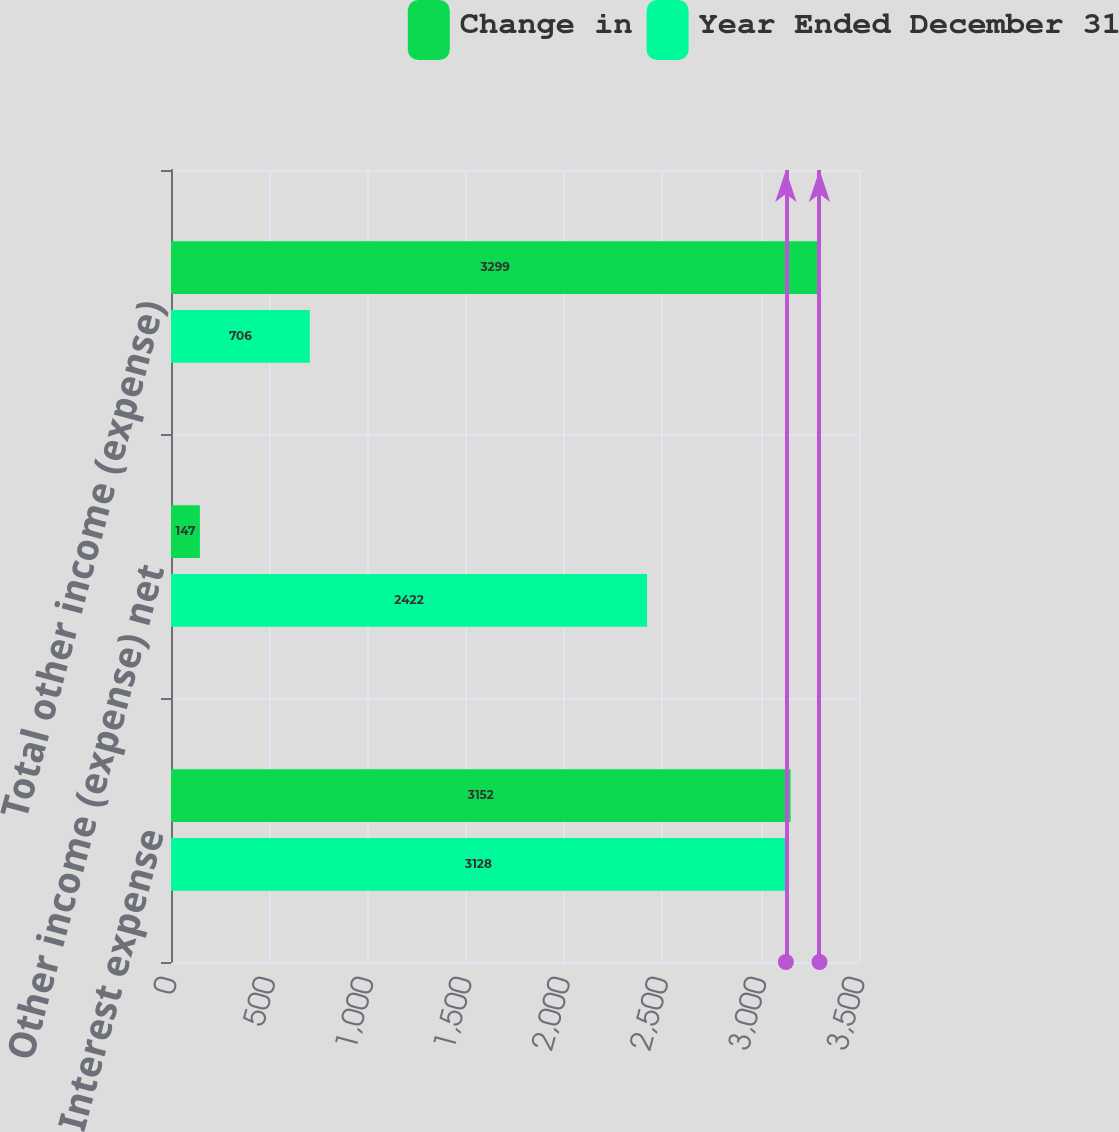<chart> <loc_0><loc_0><loc_500><loc_500><stacked_bar_chart><ecel><fcel>Interest expense<fcel>Other income (expense) net<fcel>Total other income (expense)<nl><fcel>Change in<fcel>3152<fcel>147<fcel>3299<nl><fcel>Year Ended December 31<fcel>3128<fcel>2422<fcel>706<nl></chart> 